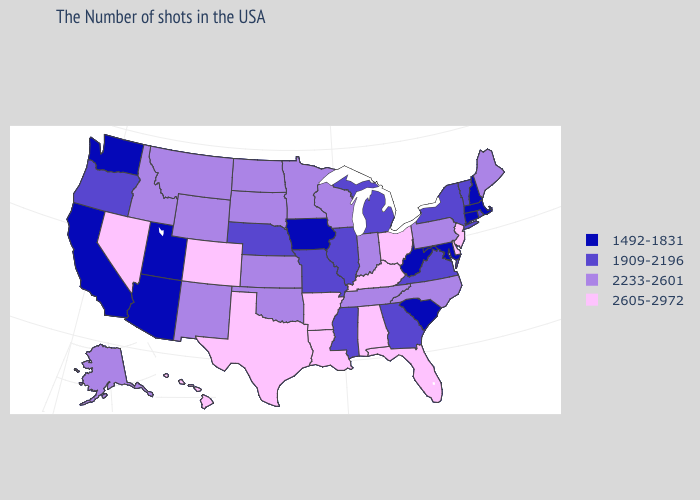Among the states that border Minnesota , which have the highest value?
Keep it brief. Wisconsin, South Dakota, North Dakota. Name the states that have a value in the range 2605-2972?
Give a very brief answer. New Jersey, Delaware, Ohio, Florida, Kentucky, Alabama, Louisiana, Arkansas, Texas, Colorado, Nevada, Hawaii. Among the states that border Washington , which have the highest value?
Short answer required. Idaho. Does Wyoming have the highest value in the USA?
Quick response, please. No. What is the value of North Carolina?
Keep it brief. 2233-2601. Which states have the lowest value in the USA?
Give a very brief answer. Massachusetts, New Hampshire, Connecticut, Maryland, South Carolina, West Virginia, Iowa, Utah, Arizona, California, Washington. Name the states that have a value in the range 2605-2972?
Give a very brief answer. New Jersey, Delaware, Ohio, Florida, Kentucky, Alabama, Louisiana, Arkansas, Texas, Colorado, Nevada, Hawaii. Name the states that have a value in the range 1909-2196?
Keep it brief. Rhode Island, Vermont, New York, Virginia, Georgia, Michigan, Illinois, Mississippi, Missouri, Nebraska, Oregon. Does the map have missing data?
Be succinct. No. Name the states that have a value in the range 1909-2196?
Be succinct. Rhode Island, Vermont, New York, Virginia, Georgia, Michigan, Illinois, Mississippi, Missouri, Nebraska, Oregon. Name the states that have a value in the range 1492-1831?
Be succinct. Massachusetts, New Hampshire, Connecticut, Maryland, South Carolina, West Virginia, Iowa, Utah, Arizona, California, Washington. What is the value of Maine?
Short answer required. 2233-2601. Which states have the lowest value in the USA?
Short answer required. Massachusetts, New Hampshire, Connecticut, Maryland, South Carolina, West Virginia, Iowa, Utah, Arizona, California, Washington. Name the states that have a value in the range 2605-2972?
Short answer required. New Jersey, Delaware, Ohio, Florida, Kentucky, Alabama, Louisiana, Arkansas, Texas, Colorado, Nevada, Hawaii. What is the value of Oklahoma?
Write a very short answer. 2233-2601. 